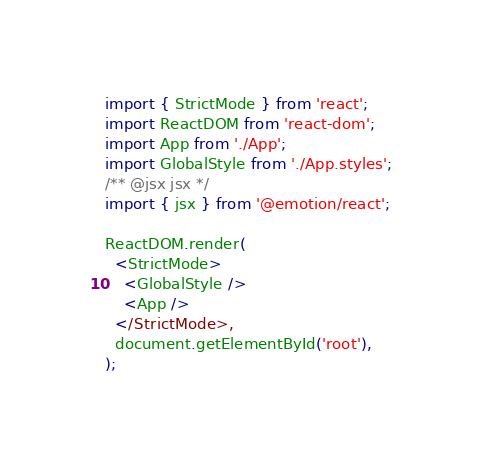Convert code to text. <code><loc_0><loc_0><loc_500><loc_500><_TypeScript_>import { StrictMode } from 'react';
import ReactDOM from 'react-dom';
import App from './App';
import GlobalStyle from './App.styles';
/** @jsx jsx */
import { jsx } from '@emotion/react';

ReactDOM.render(
  <StrictMode>
    <GlobalStyle />
    <App />
  </StrictMode>,
  document.getElementById('root'),
);
</code> 